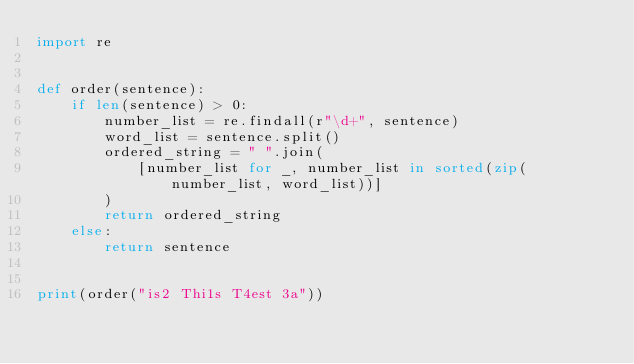<code> <loc_0><loc_0><loc_500><loc_500><_Python_>import re


def order(sentence):
    if len(sentence) > 0:
        number_list = re.findall(r"\d+", sentence)
        word_list = sentence.split()
        ordered_string = " ".join(
            [number_list for _, number_list in sorted(zip(number_list, word_list))]
        )
        return ordered_string
    else:
        return sentence


print(order("is2 Thi1s T4est 3a"))
</code> 